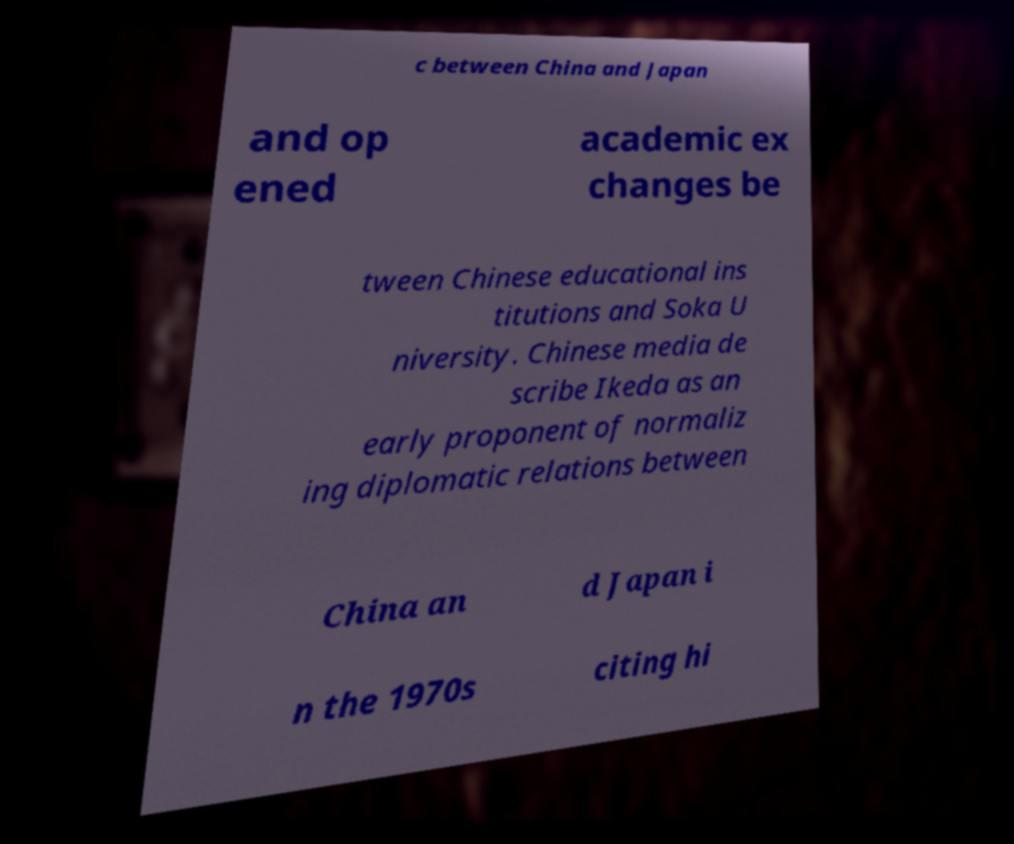Can you accurately transcribe the text from the provided image for me? c between China and Japan and op ened academic ex changes be tween Chinese educational ins titutions and Soka U niversity. Chinese media de scribe Ikeda as an early proponent of normaliz ing diplomatic relations between China an d Japan i n the 1970s citing hi 